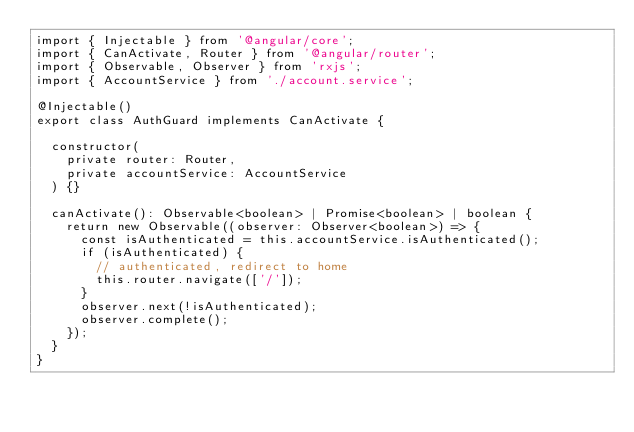<code> <loc_0><loc_0><loc_500><loc_500><_TypeScript_>import { Injectable } from '@angular/core';
import { CanActivate, Router } from '@angular/router';
import { Observable, Observer } from 'rxjs';
import { AccountService } from './account.service';

@Injectable()
export class AuthGuard implements CanActivate {

  constructor(
    private router: Router,
    private accountService: AccountService
  ) {}

  canActivate(): Observable<boolean> | Promise<boolean> | boolean {
    return new Observable((observer: Observer<boolean>) => {
      const isAuthenticated = this.accountService.isAuthenticated();
      if (isAuthenticated) {
        // authenticated, redirect to home
        this.router.navigate(['/']);
      }
      observer.next(!isAuthenticated);
      observer.complete();
    });
  }
}
</code> 